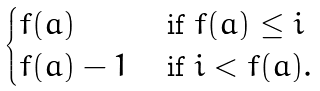<formula> <loc_0><loc_0><loc_500><loc_500>\begin{cases} f ( a ) & \text { if } f ( a ) \leq i \\ f ( a ) - 1 & \text { if } i < f ( a ) . \end{cases}</formula> 